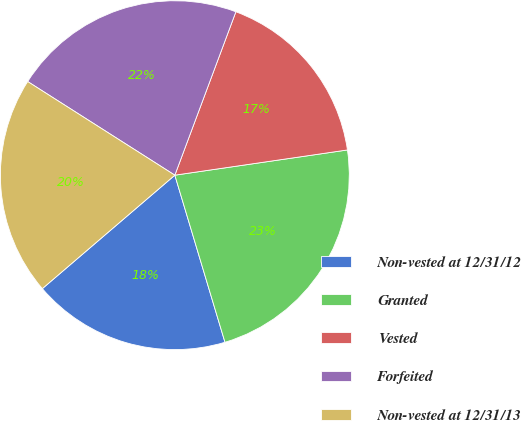<chart> <loc_0><loc_0><loc_500><loc_500><pie_chart><fcel>Non-vested at 12/31/12<fcel>Granted<fcel>Vested<fcel>Forfeited<fcel>Non-vested at 12/31/13<nl><fcel>18.37%<fcel>22.67%<fcel>17.0%<fcel>21.67%<fcel>20.29%<nl></chart> 